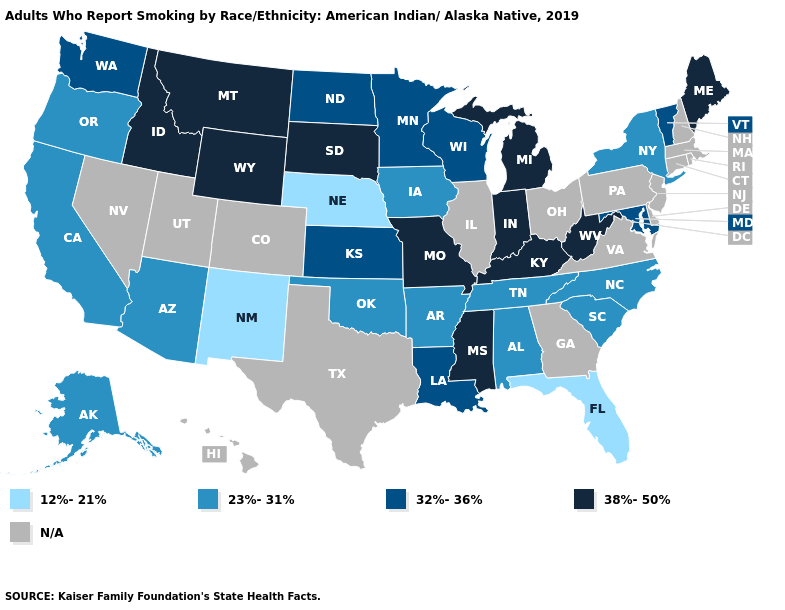Name the states that have a value in the range 32%-36%?
Keep it brief. Kansas, Louisiana, Maryland, Minnesota, North Dakota, Vermont, Washington, Wisconsin. What is the value of South Dakota?
Concise answer only. 38%-50%. Name the states that have a value in the range 12%-21%?
Answer briefly. Florida, Nebraska, New Mexico. Does Maine have the lowest value in the Northeast?
Be succinct. No. How many symbols are there in the legend?
Keep it brief. 5. What is the value of South Carolina?
Give a very brief answer. 23%-31%. What is the highest value in states that border Arizona?
Short answer required. 23%-31%. Does the first symbol in the legend represent the smallest category?
Short answer required. Yes. Among the states that border Texas , which have the lowest value?
Keep it brief. New Mexico. Name the states that have a value in the range 12%-21%?
Keep it brief. Florida, Nebraska, New Mexico. What is the value of Michigan?
Concise answer only. 38%-50%. Name the states that have a value in the range 12%-21%?
Write a very short answer. Florida, Nebraska, New Mexico. What is the value of Iowa?
Answer briefly. 23%-31%. 